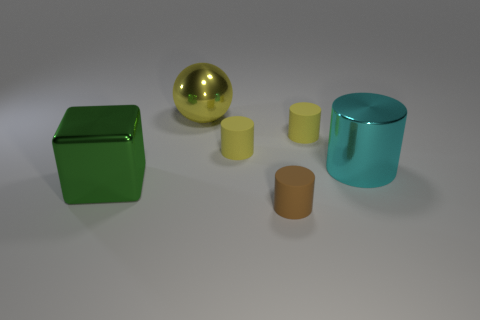Are there any green cubes that have the same size as the green object?
Ensure brevity in your answer.  No. Is the number of big yellow objects greater than the number of small yellow objects?
Provide a succinct answer. No. There is a metal object that is to the right of the yellow shiny object; is it the same size as the block that is left of the yellow metal sphere?
Your answer should be compact. Yes. What number of things are behind the large cube and left of the big yellow sphere?
Your answer should be very brief. 0. There is a metal object that is the same shape as the brown rubber thing; what is its color?
Offer a terse response. Cyan. Is the number of yellow matte things less than the number of large metallic spheres?
Provide a short and direct response. No. There is a cyan thing; is its size the same as the matte thing in front of the large green block?
Give a very brief answer. No. What color is the cylinder that is left of the matte cylinder that is in front of the big green metal cube?
Ensure brevity in your answer.  Yellow. How many things are metallic things that are on the left side of the yellow shiny object or large metallic things left of the yellow ball?
Your answer should be compact. 1. Do the metal cube and the metallic sphere have the same size?
Provide a short and direct response. Yes. 